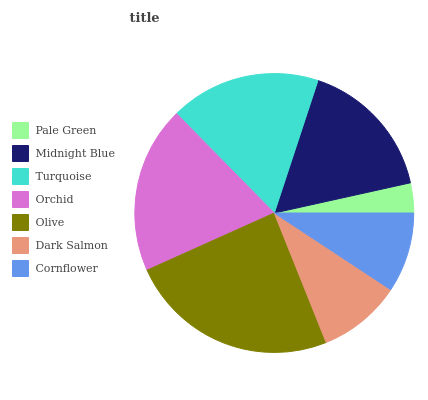Is Pale Green the minimum?
Answer yes or no. Yes. Is Olive the maximum?
Answer yes or no. Yes. Is Midnight Blue the minimum?
Answer yes or no. No. Is Midnight Blue the maximum?
Answer yes or no. No. Is Midnight Blue greater than Pale Green?
Answer yes or no. Yes. Is Pale Green less than Midnight Blue?
Answer yes or no. Yes. Is Pale Green greater than Midnight Blue?
Answer yes or no. No. Is Midnight Blue less than Pale Green?
Answer yes or no. No. Is Midnight Blue the high median?
Answer yes or no. Yes. Is Midnight Blue the low median?
Answer yes or no. Yes. Is Turquoise the high median?
Answer yes or no. No. Is Orchid the low median?
Answer yes or no. No. 